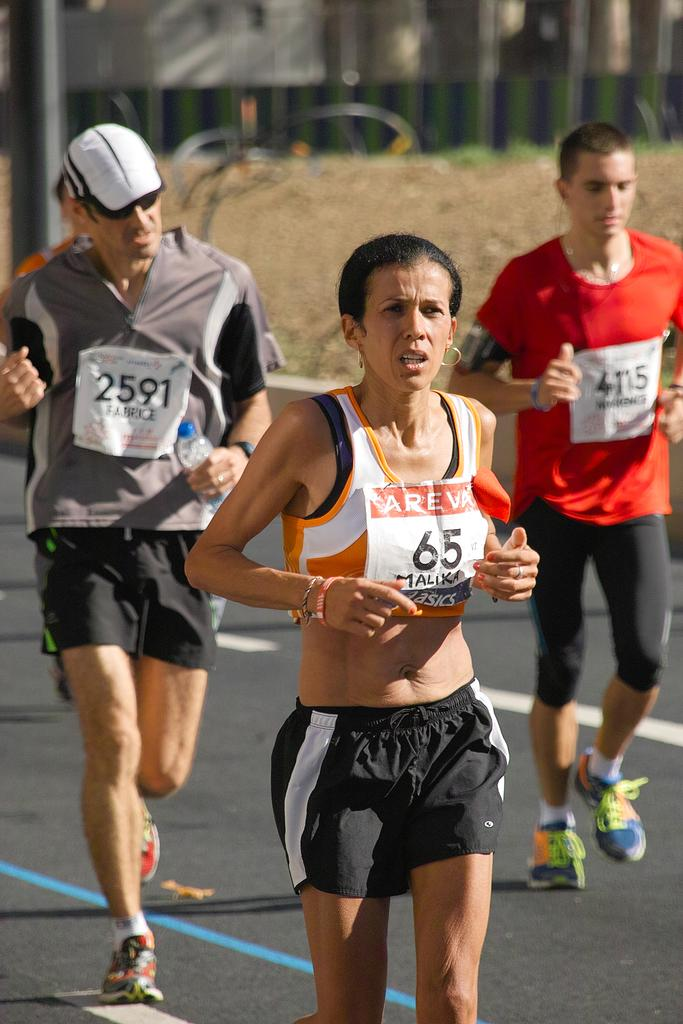<image>
Write a terse but informative summary of the picture. The man on the left has a #2591 FABRICE sign on him and the woman has #65 MALIKA on her and they are running a race with others. 